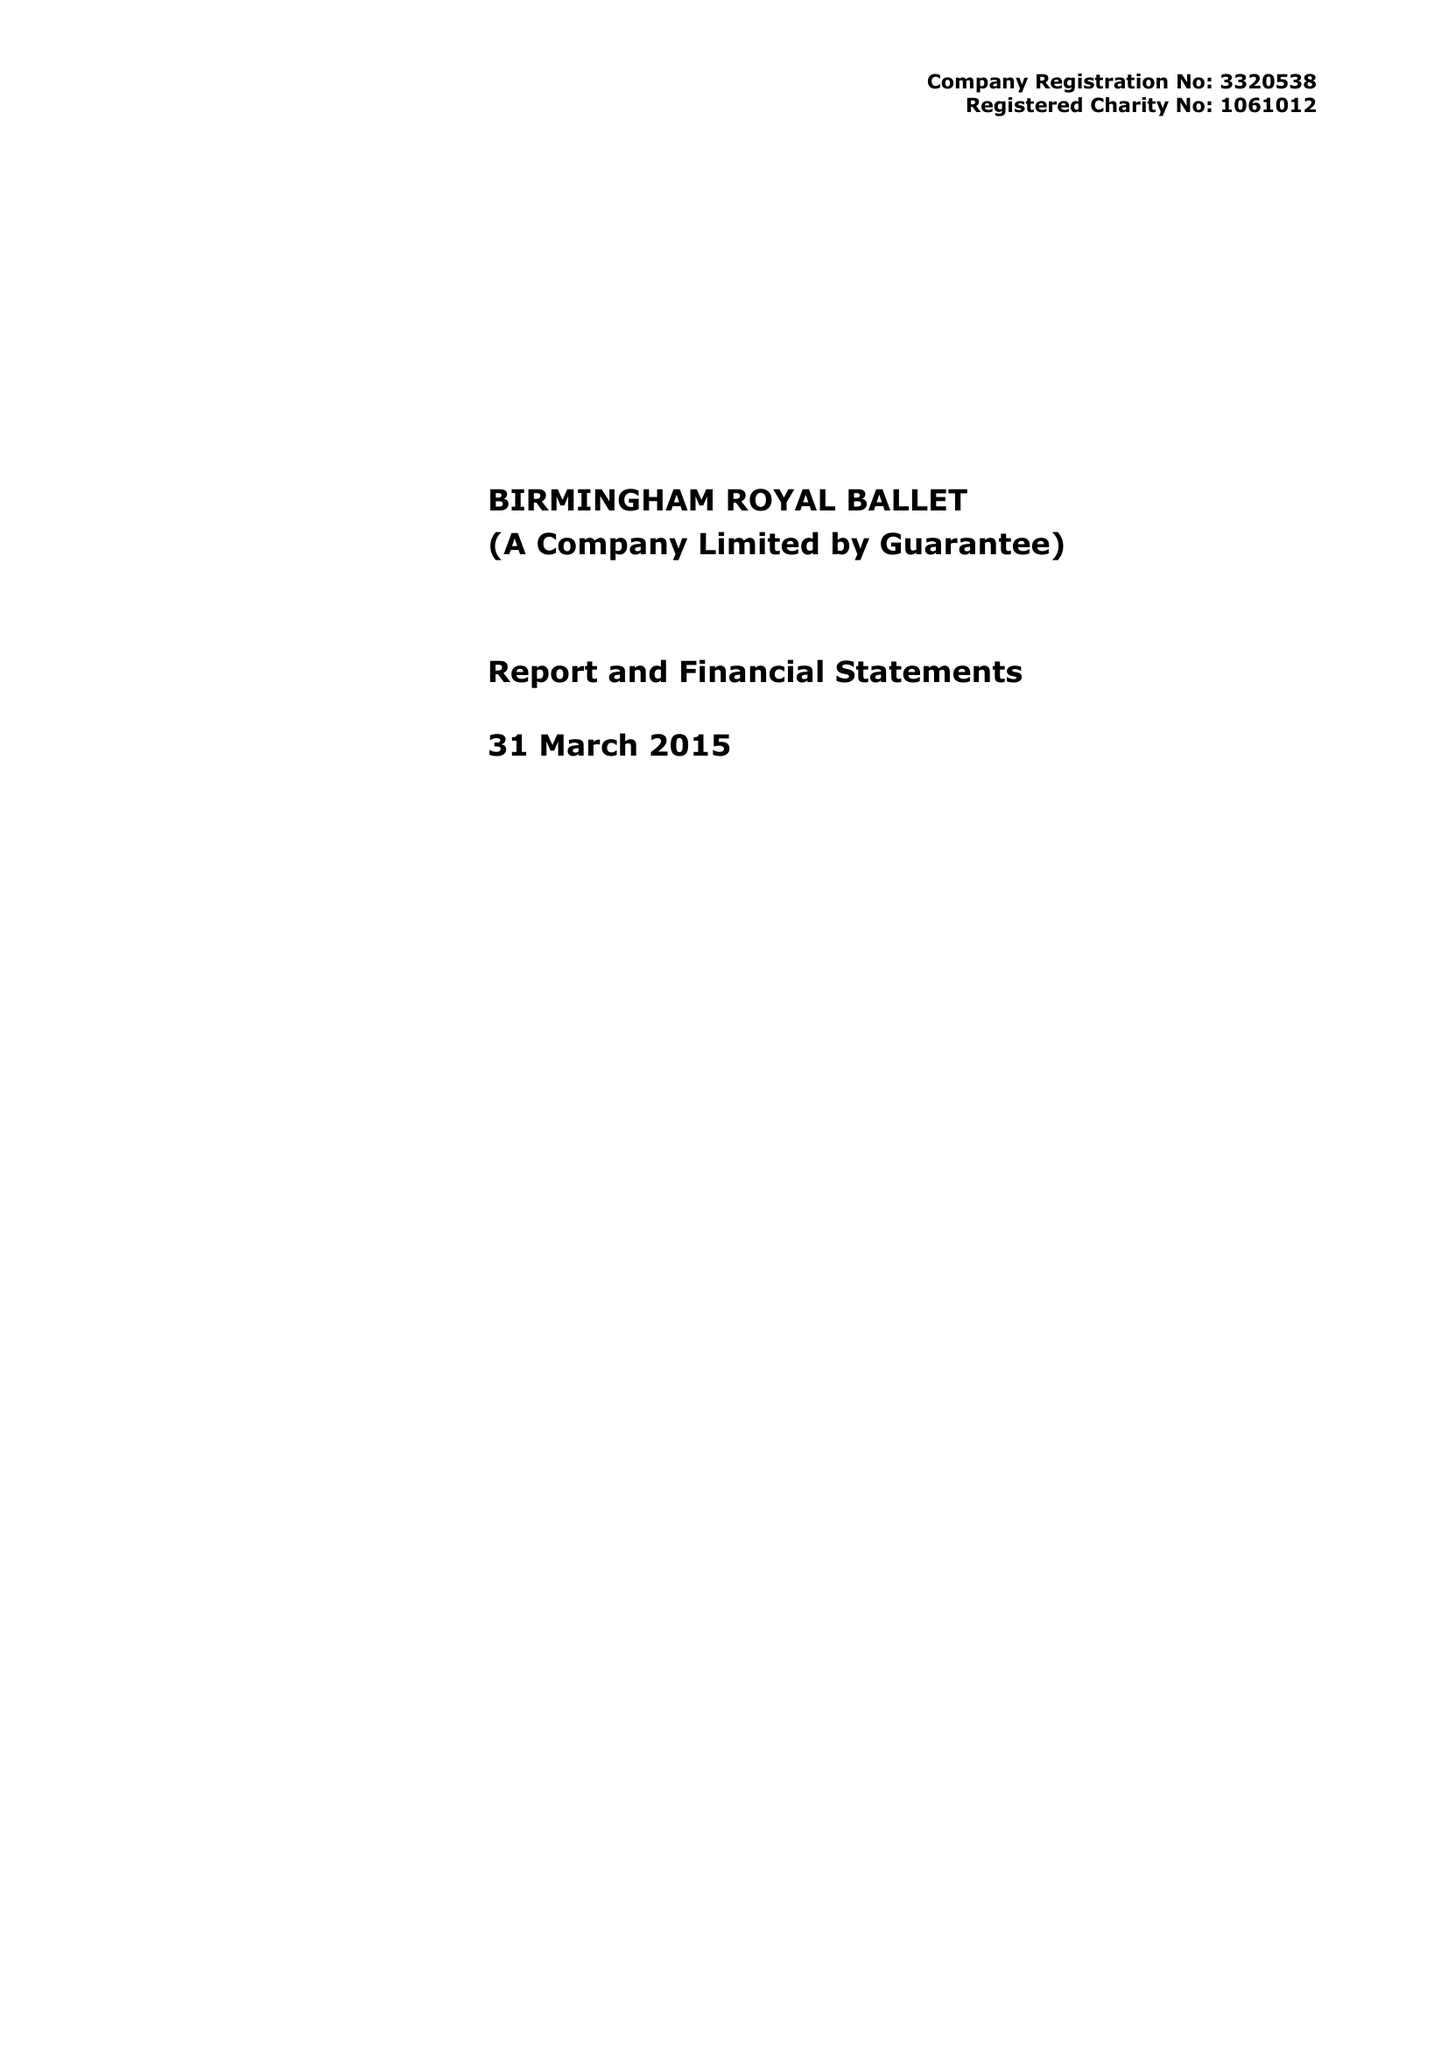What is the value for the address__post_town?
Answer the question using a single word or phrase. BIRMINGHAM 